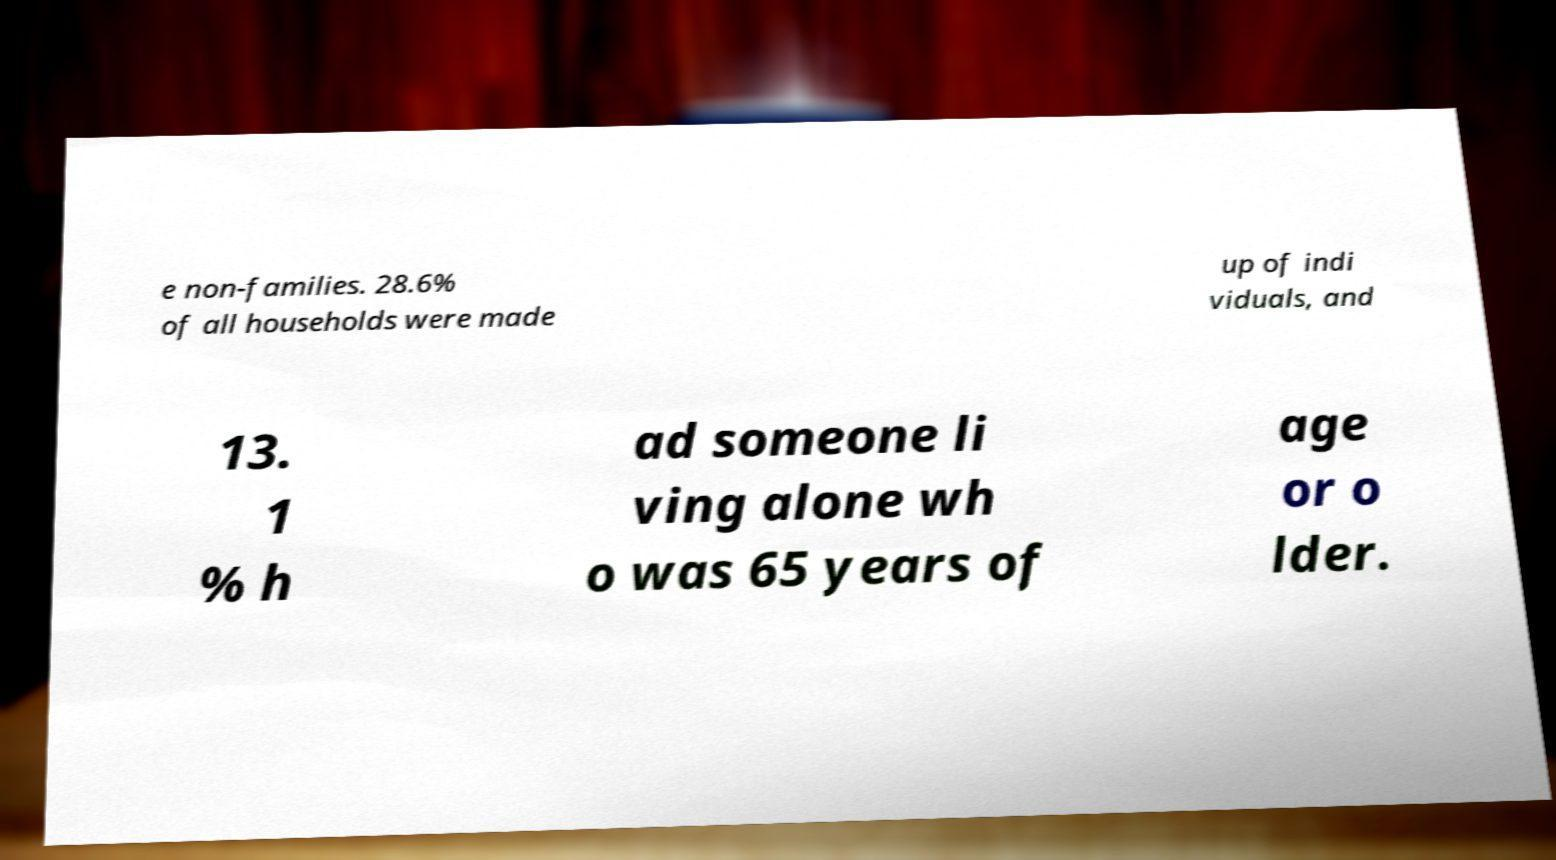Please read and relay the text visible in this image. What does it say? e non-families. 28.6% of all households were made up of indi viduals, and 13. 1 % h ad someone li ving alone wh o was 65 years of age or o lder. 